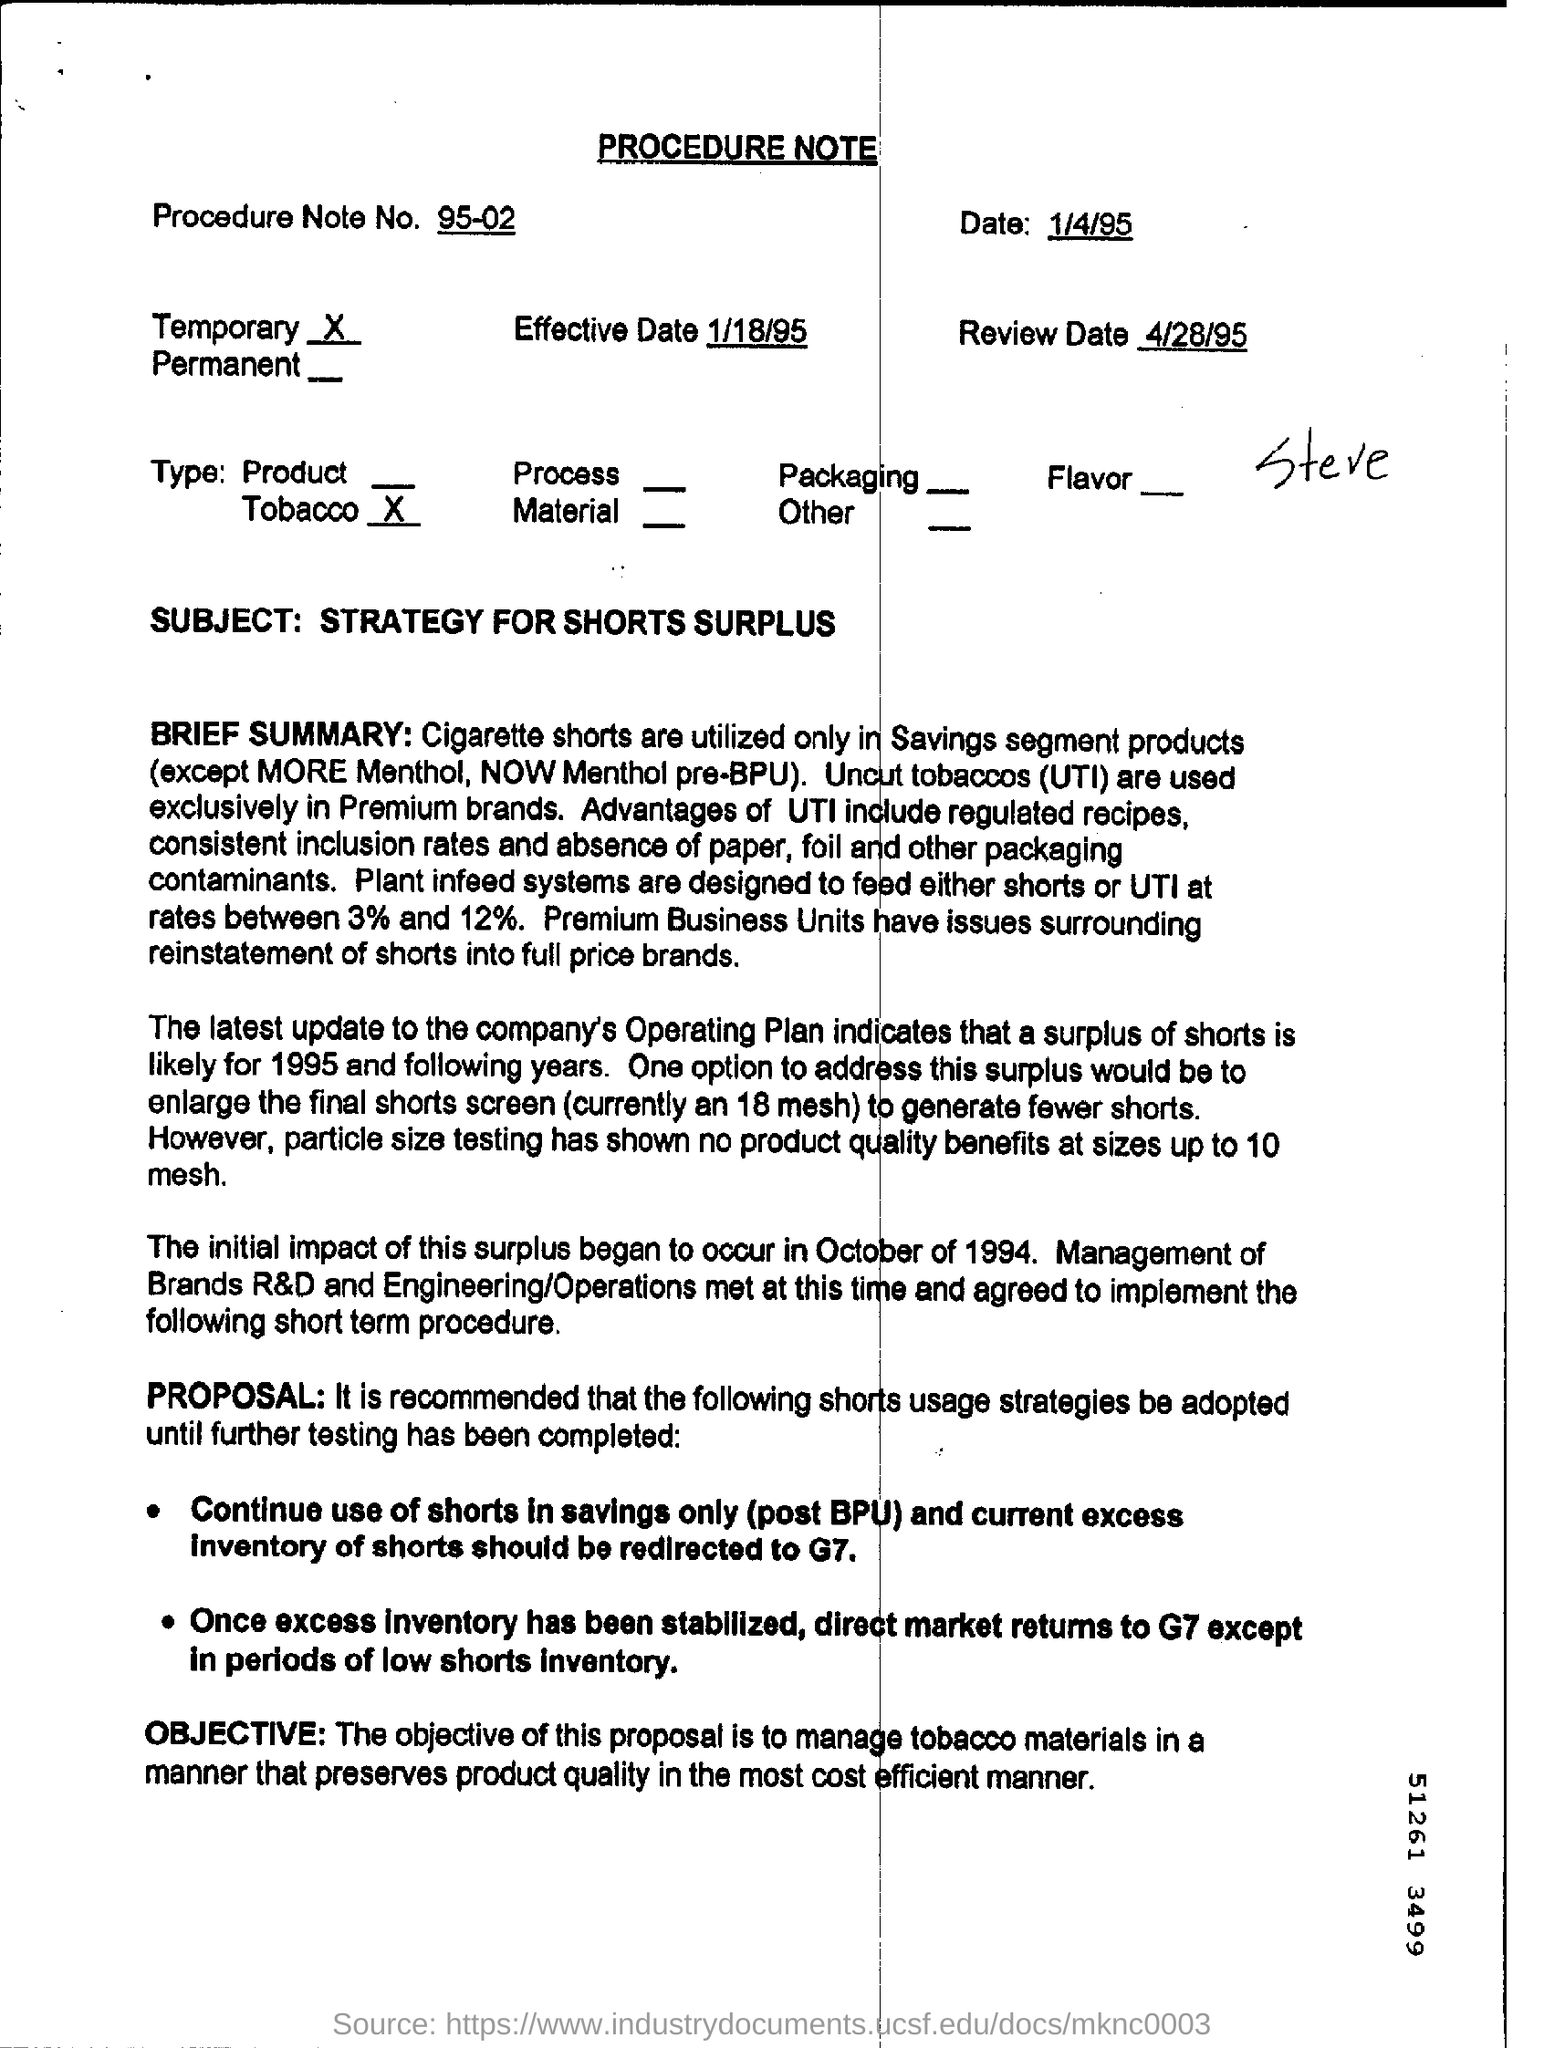Give some essential details in this illustration. The final shorts screen currently measures 18 mesh. The review is scheduled for April 28, 1995. Plant infeed systems are designed to feed either shorts or UTI at rates between 3% and 12%, ensuring efficient and accurate processing of the material. The Procedure Note No. 95-02 is a document that outlines a specific procedure. The procedure note number is 95-02. 